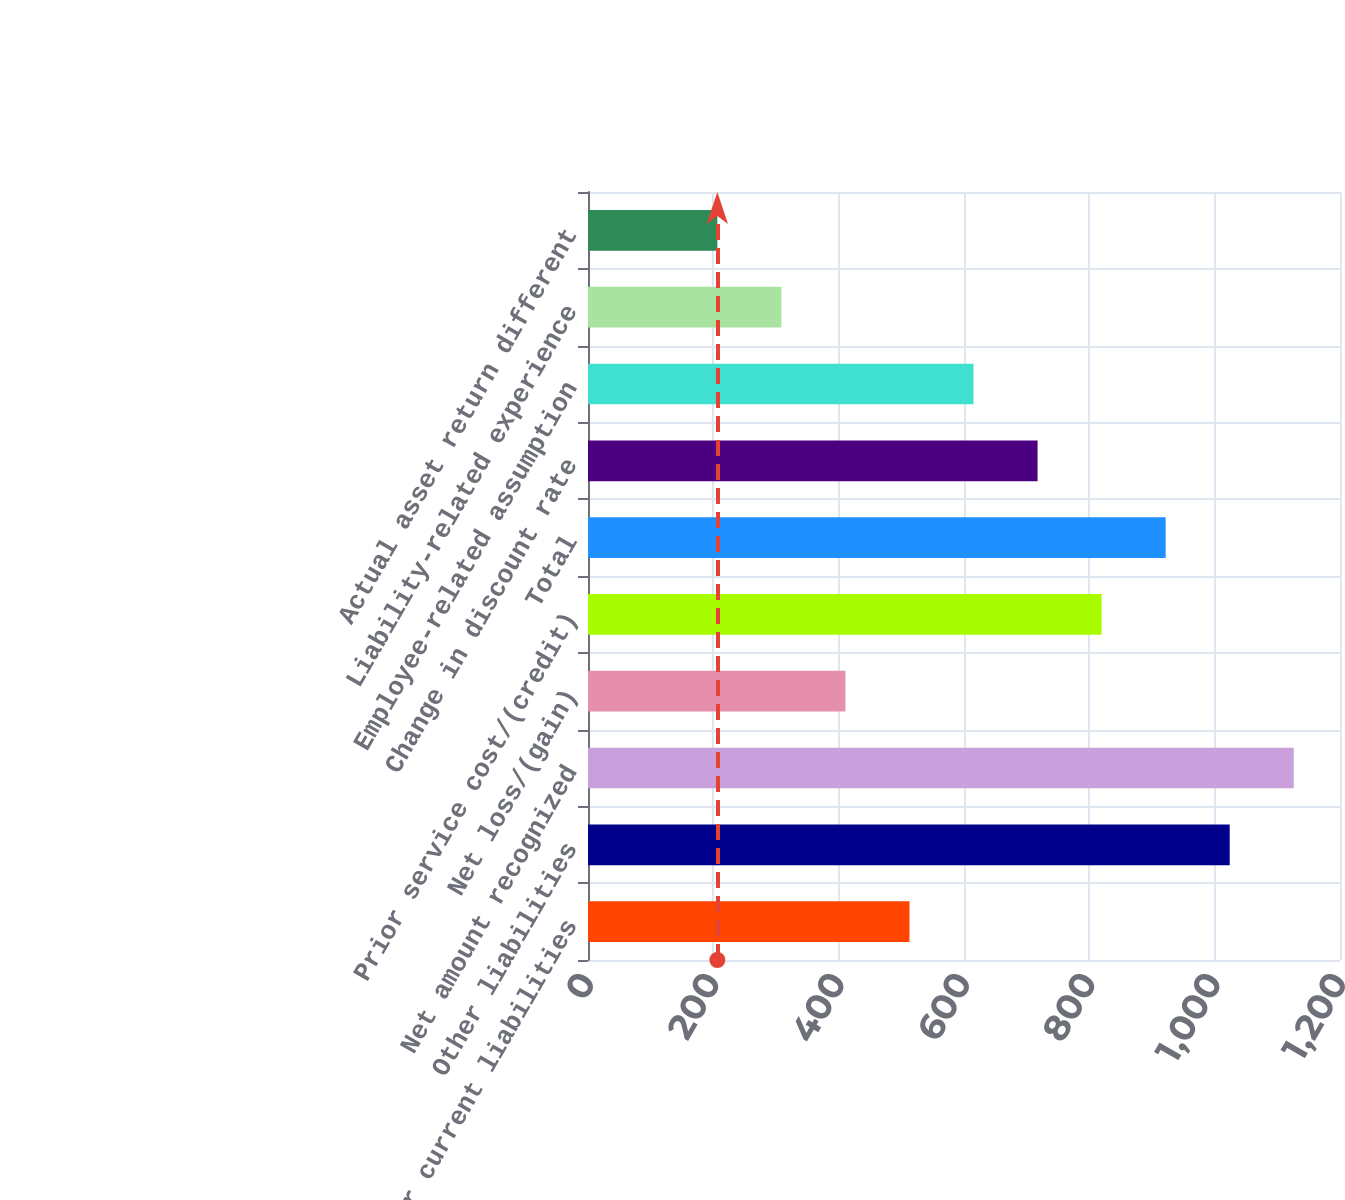Convert chart. <chart><loc_0><loc_0><loc_500><loc_500><bar_chart><fcel>Other current liabilities<fcel>Other liabilities<fcel>Net amount recognized<fcel>Net loss/(gain)<fcel>Prior service cost/(credit)<fcel>Total<fcel>Change in discount rate<fcel>Employee-related assumption<fcel>Liability-related experience<fcel>Actual asset return different<nl><fcel>513<fcel>1024<fcel>1126.2<fcel>410.8<fcel>819.6<fcel>921.8<fcel>717.4<fcel>615.2<fcel>308.6<fcel>206.4<nl></chart> 